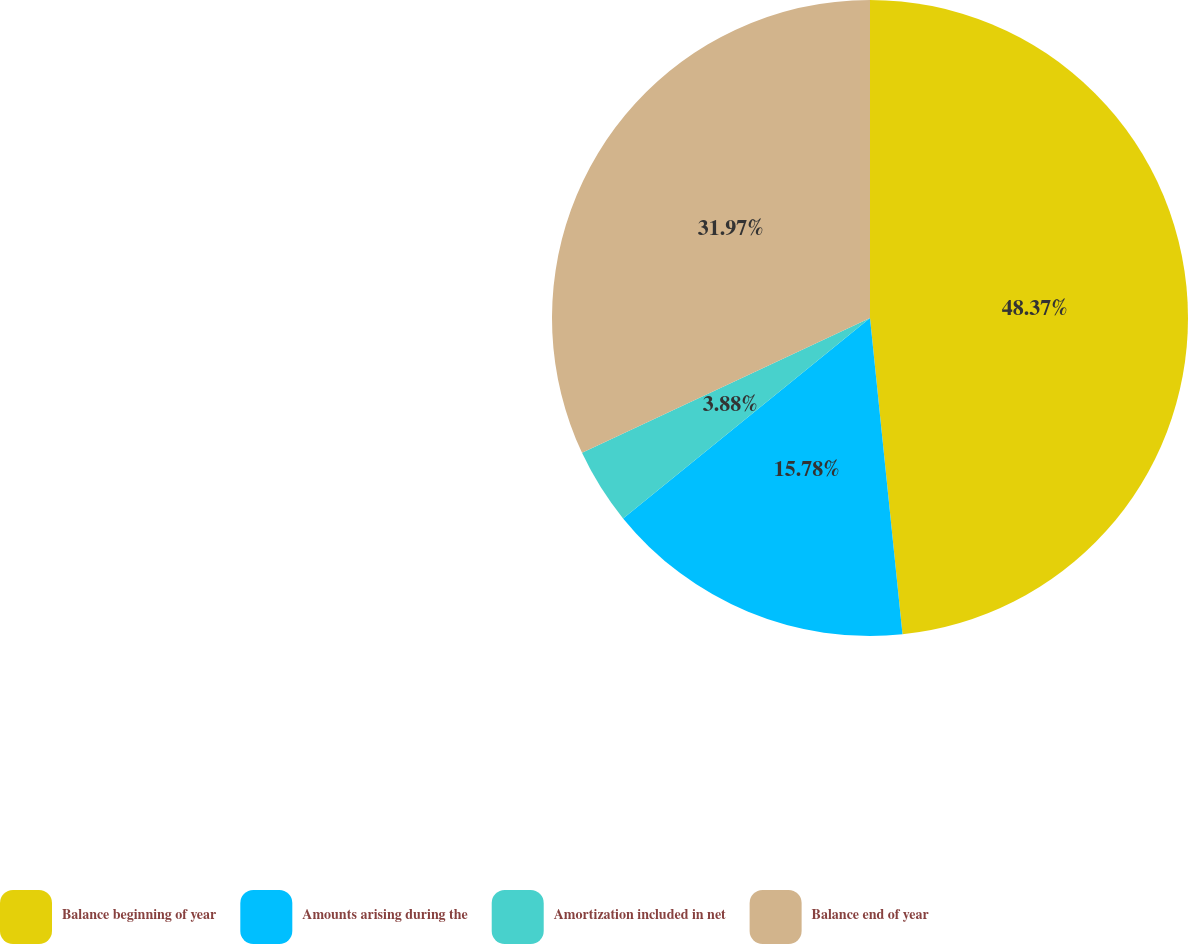<chart> <loc_0><loc_0><loc_500><loc_500><pie_chart><fcel>Balance beginning of year<fcel>Amounts arising during the<fcel>Amortization included in net<fcel>Balance end of year<nl><fcel>48.37%<fcel>15.78%<fcel>3.88%<fcel>31.97%<nl></chart> 